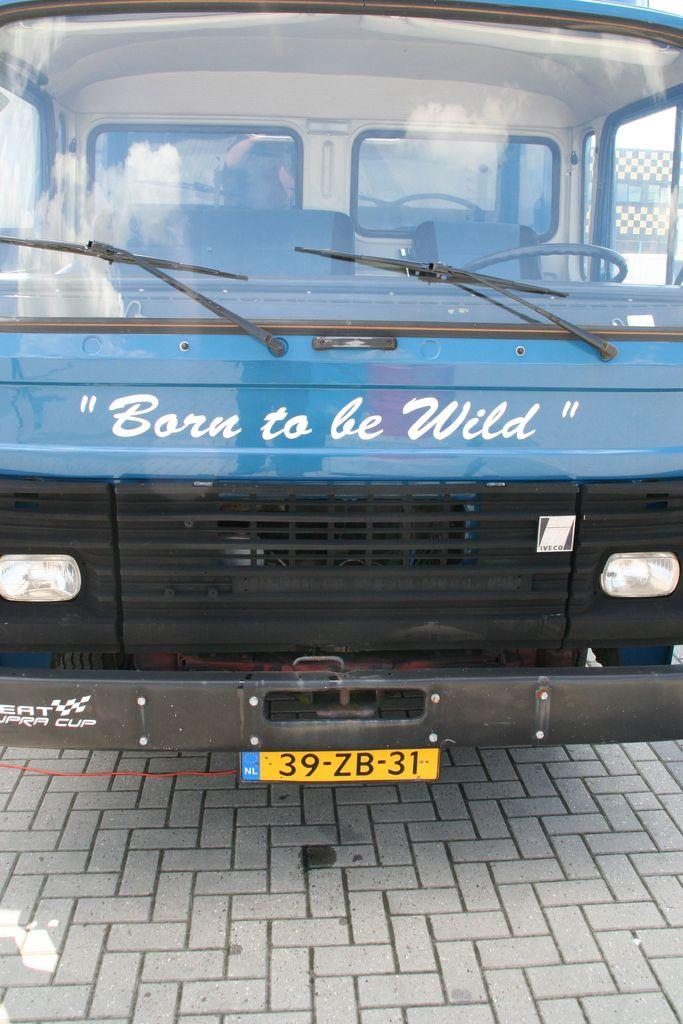<image>
Relay a brief, clear account of the picture shown. A bus which has the phrase Born to be Wild on the front. 